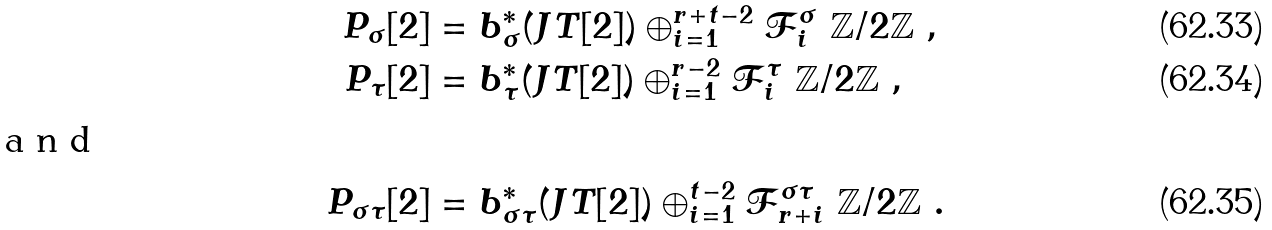Convert formula to latex. <formula><loc_0><loc_0><loc_500><loc_500>P _ { \sigma } [ 2 ] & = b _ { \sigma } ^ { * } ( J T [ 2 ] ) \oplus _ { i = 1 } ^ { r + t - 2 } { \mathcal { F } } _ { i } ^ { \sigma } \ { \mathbb { Z } } / 2 { \mathbb { Z } } \ , \\ P _ { \tau } [ 2 ] & = b _ { \tau } ^ { * } ( J T [ 2 ] ) \oplus _ { i = 1 } ^ { r - 2 } { \mathcal { F } } _ { i } ^ { \tau } \ { \mathbb { Z } } / 2 { \mathbb { Z } } \ , \\ \intertext { a n d } P _ { \sigma \tau } [ 2 ] & = b _ { \sigma \tau } ^ { * } ( J T [ 2 ] ) \oplus _ { i = 1 } ^ { t - 2 } { \mathcal { F } } _ { r + i } ^ { \sigma \tau } \ { \mathbb { Z } } / 2 { \mathbb { Z } } \ .</formula> 